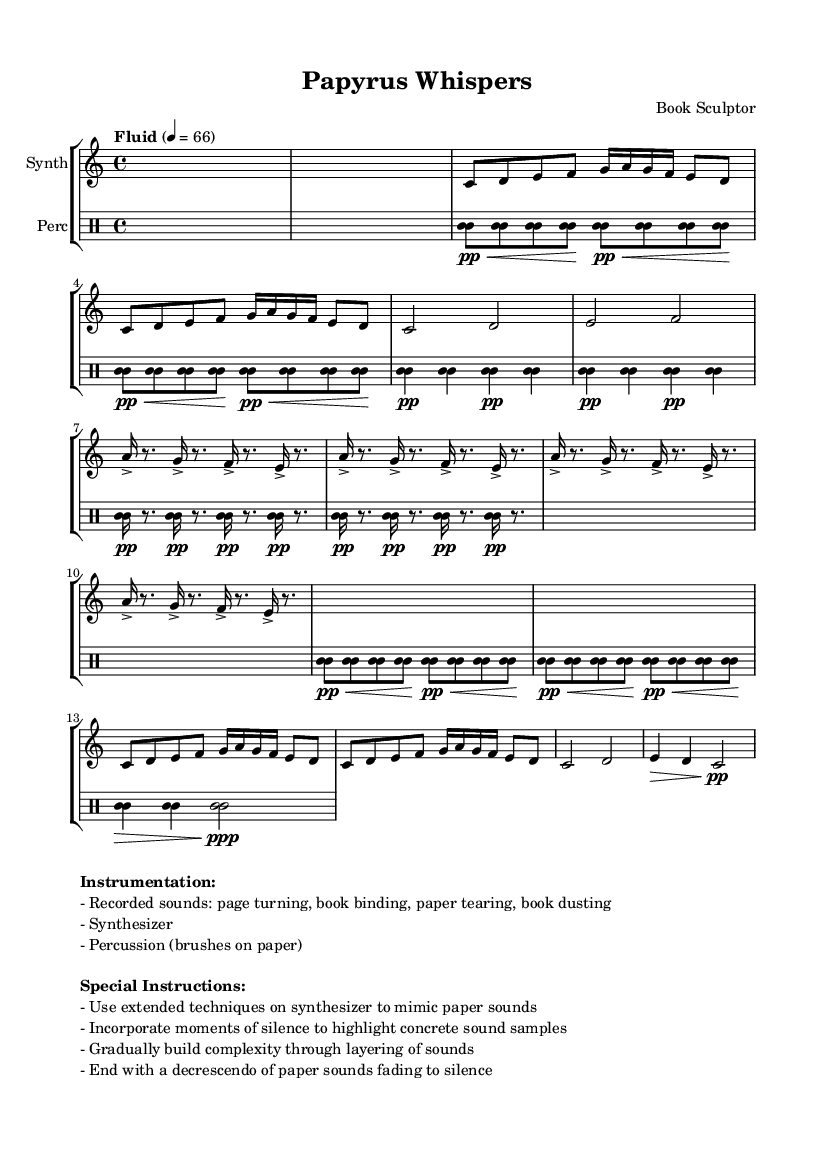What is the time signature of this music? The time signature is indicated at the beginning of the score, which is 4/4, meaning there are four beats in each measure.
Answer: 4/4 What is the initial tempo marking given for this composition? The tempo marking is found just above the staff, indicating "Fluid" with a metronomic setting of 66 beats per minute.
Answer: Fluid 4 = 66 How many sections does the synthesized part have? By examining the structure of the synthesizer part, we can identify three main sections: Introduction, Section A (and its variation), and Section B.
Answer: Three What type of sounds are emphasized in the special instructions for performance? The special instructions highlight the use of sounds made during book restoration activities, such as turning pages, binding, and tearing paper.
Answer: Paper sounds In which section does the percussion feature the paper tearing ostinato? The percussion section clearly marks the paper tearing ostinato occurring during Section B, where rapid notes represent tearing sounds.
Answer: Section B How does the piece conclude? The coda section indicates a gradual decrease in volume with a fading effect, emphasizing the final moments of paper sounds leading to silence.
Answer: Decrescendo 